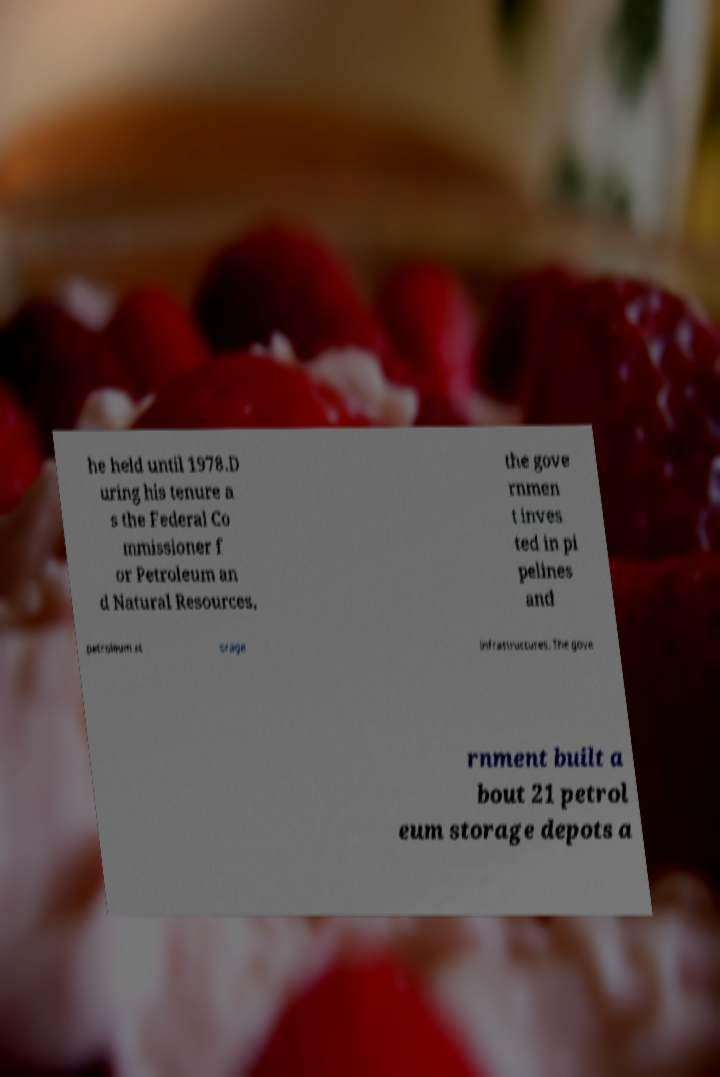Can you read and provide the text displayed in the image?This photo seems to have some interesting text. Can you extract and type it out for me? he held until 1978.D uring his tenure a s the Federal Co mmissioner f or Petroleum an d Natural Resources, the gove rnmen t inves ted in pi pelines and petroleum st orage infrastructures. The gove rnment built a bout 21 petrol eum storage depots a 